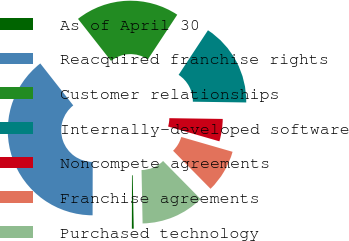Convert chart. <chart><loc_0><loc_0><loc_500><loc_500><pie_chart><fcel>As of April 30<fcel>Reacquired franchise rights<fcel>Customer relationships<fcel>Internally-developed software<fcel>Noncompete agreements<fcel>Franchise agreements<fcel>Purchased technology<nl><fcel>0.35%<fcel>39.37%<fcel>19.86%<fcel>15.96%<fcel>4.25%<fcel>8.15%<fcel>12.06%<nl></chart> 